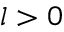Convert formula to latex. <formula><loc_0><loc_0><loc_500><loc_500>l > 0</formula> 